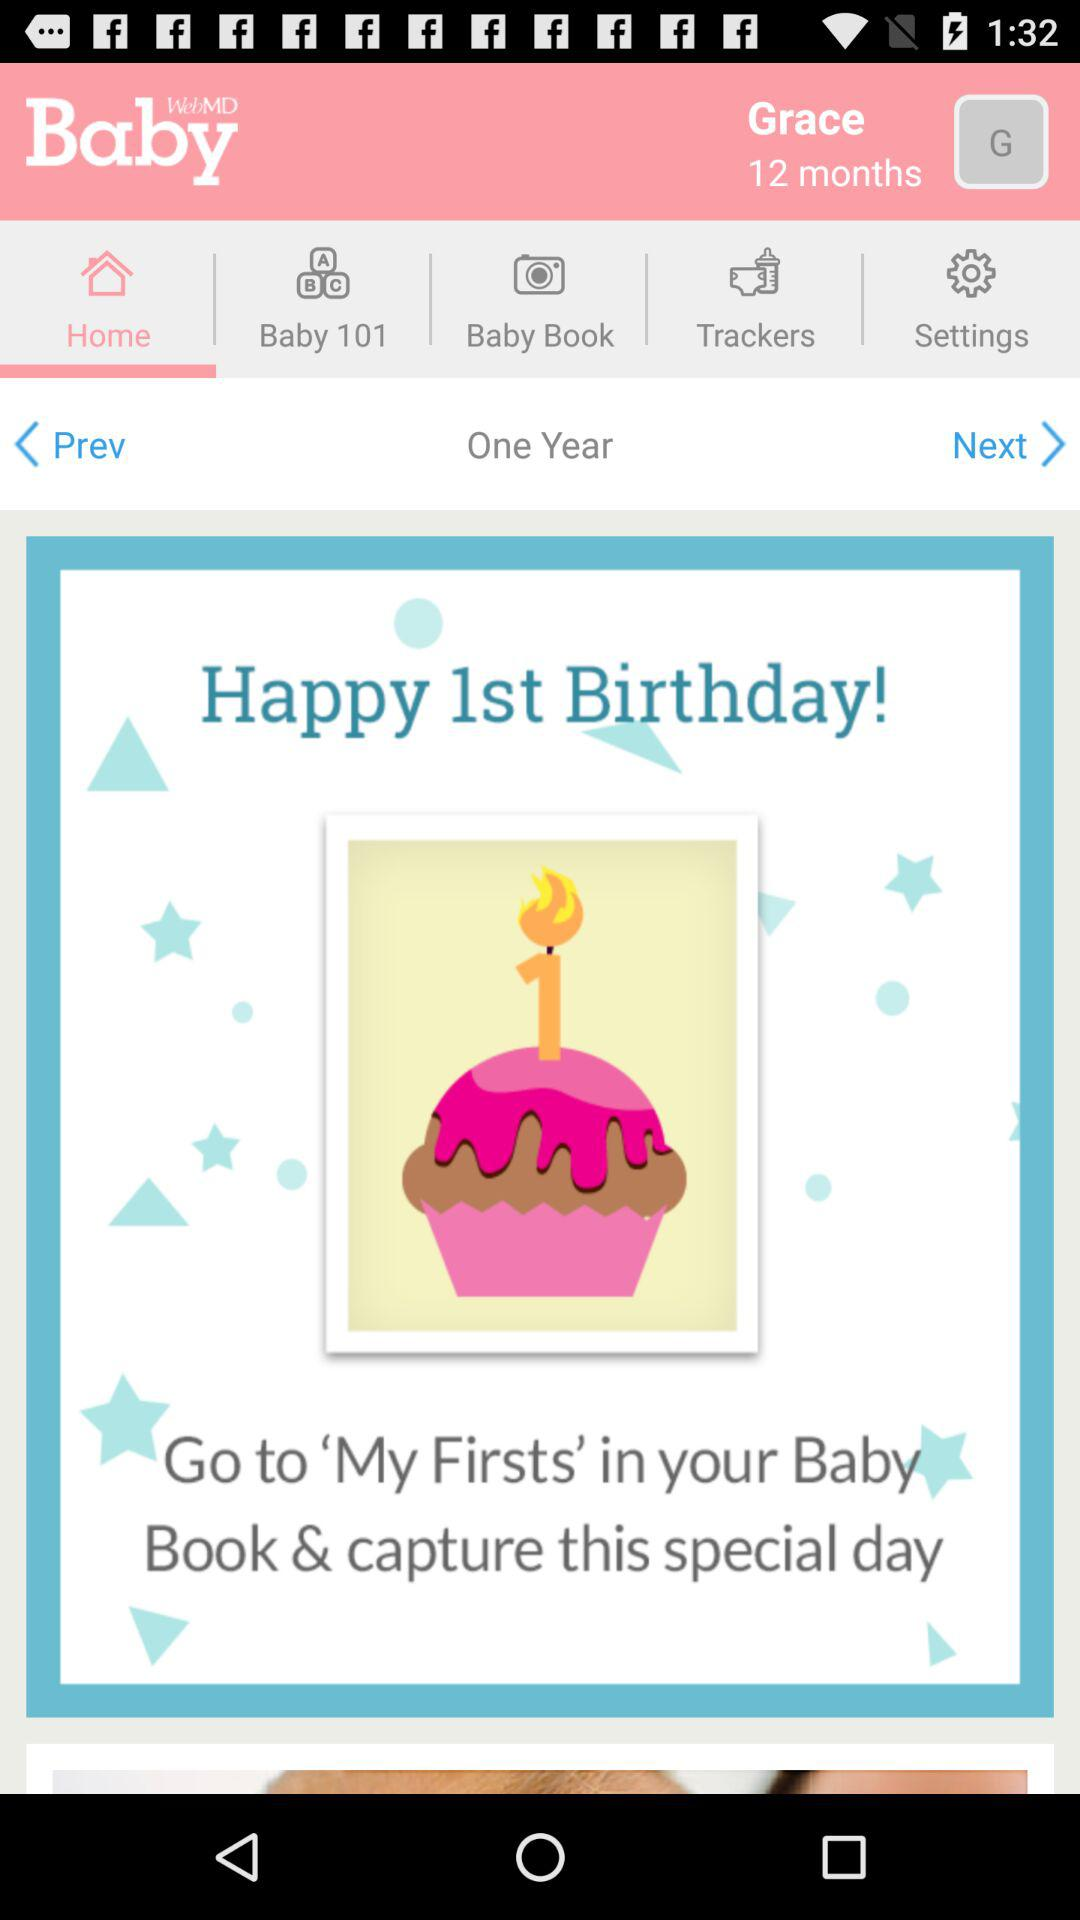How many months old is Grace?
Answer the question using a single word or phrase. 12 months 